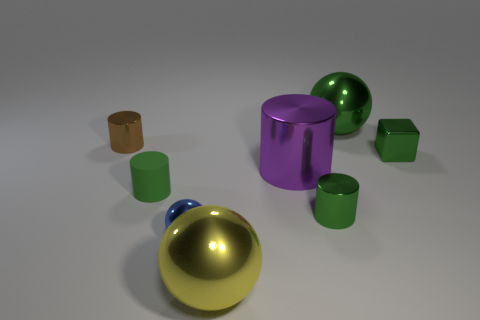Which objects in the image seem to be the furthest away? The small brown cylinder in the back appears to be the furthest away, given its size relative to the other objects and its position in the scene. 